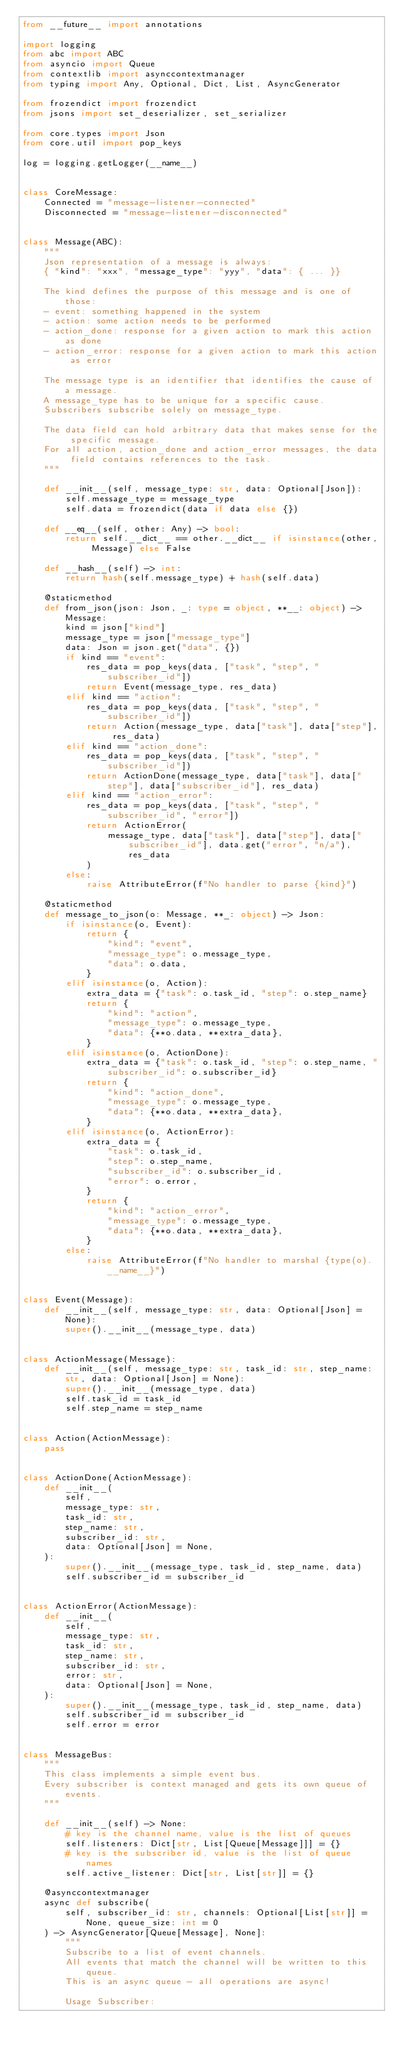Convert code to text. <code><loc_0><loc_0><loc_500><loc_500><_Python_>from __future__ import annotations

import logging
from abc import ABC
from asyncio import Queue
from contextlib import asynccontextmanager
from typing import Any, Optional, Dict, List, AsyncGenerator

from frozendict import frozendict
from jsons import set_deserializer, set_serializer

from core.types import Json
from core.util import pop_keys

log = logging.getLogger(__name__)


class CoreMessage:
    Connected = "message-listener-connected"
    Disconnected = "message-listener-disconnected"


class Message(ABC):
    """
    Json representation of a message is always:
    { "kind": "xxx", "message_type": "yyy", "data": { ... }}

    The kind defines the purpose of this message and is one of those:
    - event: something happened in the system
    - action: some action needs to be performed
    - action_done: response for a given action to mark this action as done
    - action_error: response for a given action to mark this action as error

    The message type is an identifier that identifies the cause of a message.
    A message_type has to be unique for a specific cause.
    Subscribers subscribe solely on message_type.

    The data field can hold arbitrary data that makes sense for the specific message.
    For all action, action_done and action_error messages, the data field contains references to the task.
    """

    def __init__(self, message_type: str, data: Optional[Json]):
        self.message_type = message_type
        self.data = frozendict(data if data else {})

    def __eq__(self, other: Any) -> bool:
        return self.__dict__ == other.__dict__ if isinstance(other, Message) else False

    def __hash__(self) -> int:
        return hash(self.message_type) + hash(self.data)

    @staticmethod
    def from_json(json: Json, _: type = object, **__: object) -> Message:
        kind = json["kind"]
        message_type = json["message_type"]
        data: Json = json.get("data", {})
        if kind == "event":
            res_data = pop_keys(data, ["task", "step", "subscriber_id"])
            return Event(message_type, res_data)
        elif kind == "action":
            res_data = pop_keys(data, ["task", "step", "subscriber_id"])
            return Action(message_type, data["task"], data["step"], res_data)
        elif kind == "action_done":
            res_data = pop_keys(data, ["task", "step", "subscriber_id"])
            return ActionDone(message_type, data["task"], data["step"], data["subscriber_id"], res_data)
        elif kind == "action_error":
            res_data = pop_keys(data, ["task", "step", "subscriber_id", "error"])
            return ActionError(
                message_type, data["task"], data["step"], data["subscriber_id"], data.get("error", "n/a"), res_data
            )
        else:
            raise AttributeError(f"No handler to parse {kind}")

    @staticmethod
    def message_to_json(o: Message, **_: object) -> Json:
        if isinstance(o, Event):
            return {
                "kind": "event",
                "message_type": o.message_type,
                "data": o.data,
            }
        elif isinstance(o, Action):
            extra_data = {"task": o.task_id, "step": o.step_name}
            return {
                "kind": "action",
                "message_type": o.message_type,
                "data": {**o.data, **extra_data},
            }
        elif isinstance(o, ActionDone):
            extra_data = {"task": o.task_id, "step": o.step_name, "subscriber_id": o.subscriber_id}
            return {
                "kind": "action_done",
                "message_type": o.message_type,
                "data": {**o.data, **extra_data},
            }
        elif isinstance(o, ActionError):
            extra_data = {
                "task": o.task_id,
                "step": o.step_name,
                "subscriber_id": o.subscriber_id,
                "error": o.error,
            }
            return {
                "kind": "action_error",
                "message_type": o.message_type,
                "data": {**o.data, **extra_data},
            }
        else:
            raise AttributeError(f"No handler to marshal {type(o).__name__}")


class Event(Message):
    def __init__(self, message_type: str, data: Optional[Json] = None):
        super().__init__(message_type, data)


class ActionMessage(Message):
    def __init__(self, message_type: str, task_id: str, step_name: str, data: Optional[Json] = None):
        super().__init__(message_type, data)
        self.task_id = task_id
        self.step_name = step_name


class Action(ActionMessage):
    pass


class ActionDone(ActionMessage):
    def __init__(
        self,
        message_type: str,
        task_id: str,
        step_name: str,
        subscriber_id: str,
        data: Optional[Json] = None,
    ):
        super().__init__(message_type, task_id, step_name, data)
        self.subscriber_id = subscriber_id


class ActionError(ActionMessage):
    def __init__(
        self,
        message_type: str,
        task_id: str,
        step_name: str,
        subscriber_id: str,
        error: str,
        data: Optional[Json] = None,
    ):
        super().__init__(message_type, task_id, step_name, data)
        self.subscriber_id = subscriber_id
        self.error = error


class MessageBus:
    """
    This class implements a simple event bus.
    Every subscriber is context managed and gets its own queue of events.
    """

    def __init__(self) -> None:
        # key is the channel name, value is the list of queues
        self.listeners: Dict[str, List[Queue[Message]]] = {}
        # key is the subscriber id, value is the list of queue names
        self.active_listener: Dict[str, List[str]] = {}

    @asynccontextmanager
    async def subscribe(
        self, subscriber_id: str, channels: Optional[List[str]] = None, queue_size: int = 0
    ) -> AsyncGenerator[Queue[Message], None]:
        """
        Subscribe to a list of event channels.
        All events that match the channel will be written to this queue.
        This is an async queue - all operations are async!

        Usage Subscriber:</code> 